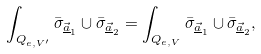Convert formula to latex. <formula><loc_0><loc_0><loc_500><loc_500>\int _ { Q _ { e , V ^ { \prime } } } \bar { \sigma } _ { \underline { \vec { a } } _ { 1 } } \cup \bar { \sigma } _ { \underline { \vec { a } } _ { 2 } } = \int _ { Q _ { e , V } } \bar { \sigma } _ { \underline { \vec { a } } _ { 1 } } \cup \bar { \sigma } _ { \underline { \vec { a } } _ { 2 } } ,</formula> 